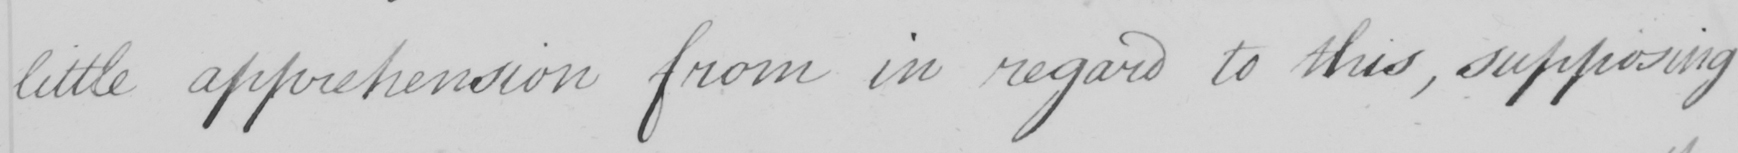Can you tell me what this handwritten text says? little apprehension from in regard to this , supposing 